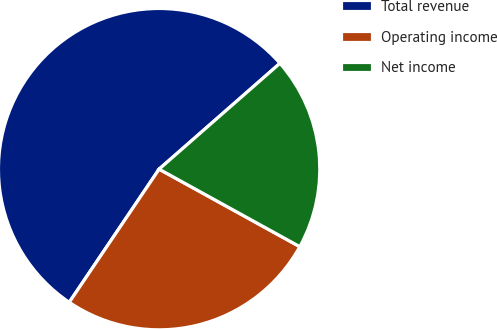Convert chart. <chart><loc_0><loc_0><loc_500><loc_500><pie_chart><fcel>Total revenue<fcel>Operating income<fcel>Net income<nl><fcel>54.1%<fcel>26.43%<fcel>19.46%<nl></chart> 